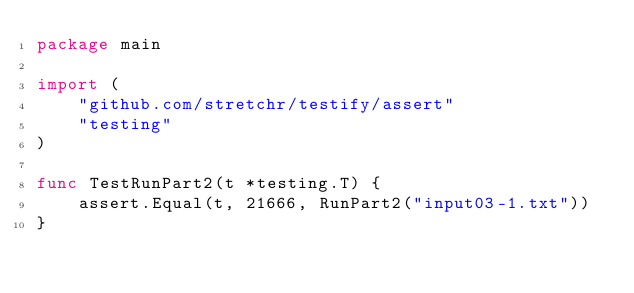Convert code to text. <code><loc_0><loc_0><loc_500><loc_500><_Go_>package main

import (
	"github.com/stretchr/testify/assert"
	"testing"
)

func TestRunPart2(t *testing.T) {
	assert.Equal(t, 21666, RunPart2("input03-1.txt"))
}
</code> 